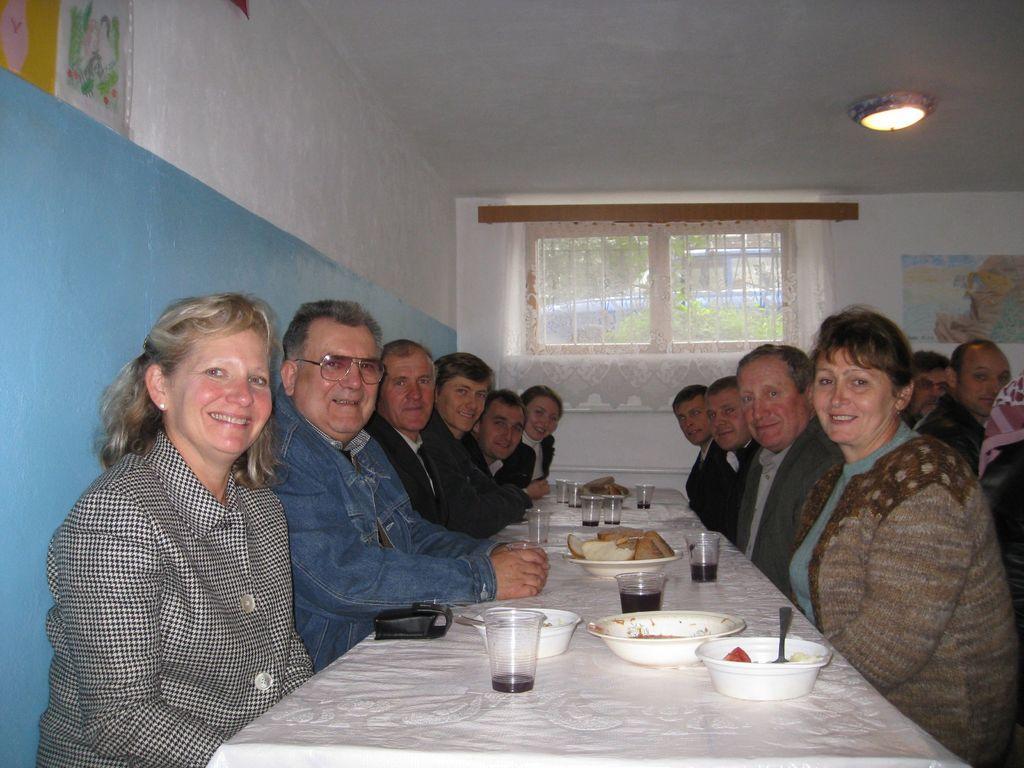How would you summarize this image in a sentence or two? In this image i can see a group of people are sitting on a chair in front of a table. On the table we have few glasses and a couple of objects on it. 